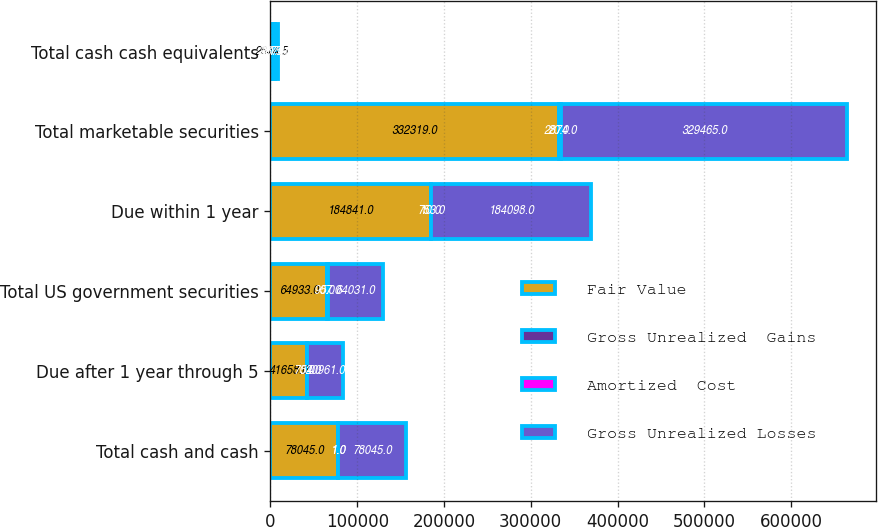Convert chart to OTSL. <chart><loc_0><loc_0><loc_500><loc_500><stacked_bar_chart><ecel><fcel>Total cash and cash<fcel>Due after 1 year through 5<fcel>Total US government securities<fcel>Due within 1 year<fcel>Total marketable securities<fcel>Total cash cash equivalents<nl><fcel>Fair Value<fcel>78045<fcel>41658<fcel>64933<fcel>184841<fcel>332319<fcel>2874.5<nl><fcel>Gross Unrealized  Gains<fcel>1<fcel>5<fcel>5<fcel>10<fcel>20<fcel>21<nl><fcel>Amortized  Cost<fcel>1<fcel>702<fcel>907<fcel>753<fcel>2874<fcel>2875<nl><fcel>Gross Unrealized Losses<fcel>78045<fcel>40961<fcel>64031<fcel>184098<fcel>329465<fcel>2874.5<nl></chart> 